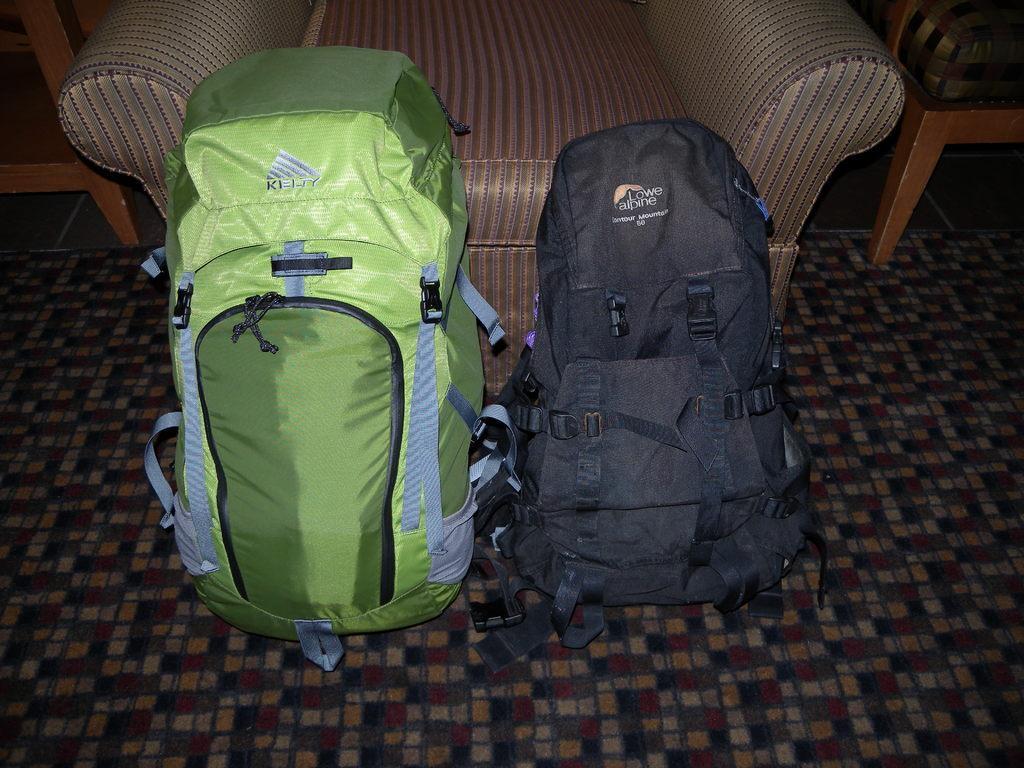In one or two sentences, can you explain what this image depicts? There are two backpacks on the floor. There is a sofa and two chairs beside it. On the floor there is a carpet. 